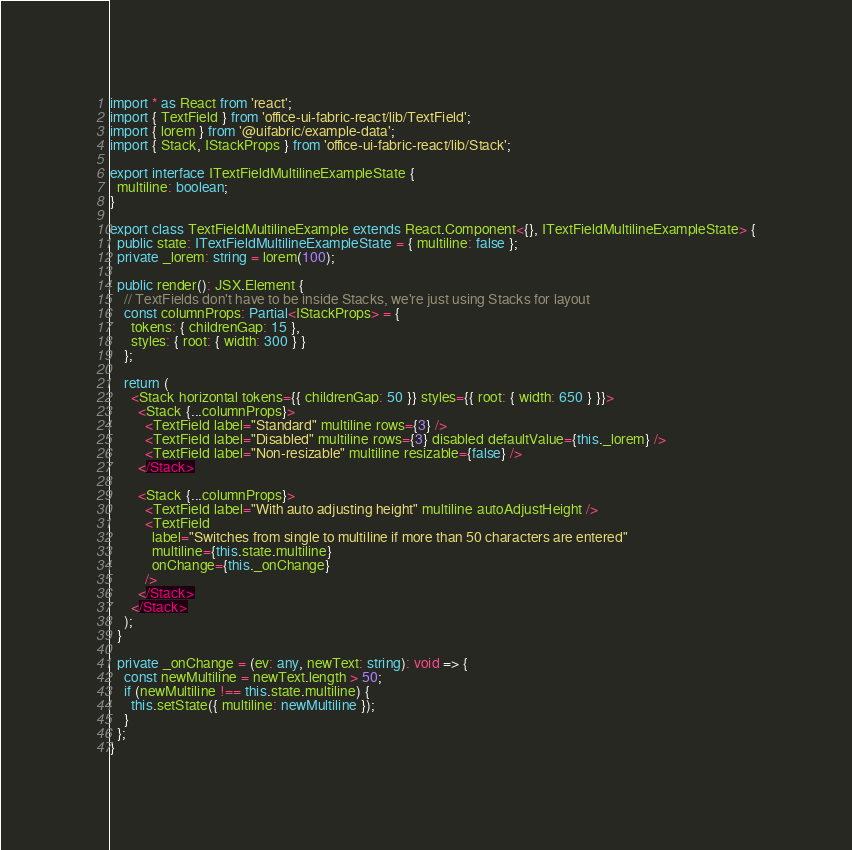Convert code to text. <code><loc_0><loc_0><loc_500><loc_500><_TypeScript_>import * as React from 'react';
import { TextField } from 'office-ui-fabric-react/lib/TextField';
import { lorem } from '@uifabric/example-data';
import { Stack, IStackProps } from 'office-ui-fabric-react/lib/Stack';

export interface ITextFieldMultilineExampleState {
  multiline: boolean;
}

export class TextFieldMultilineExample extends React.Component<{}, ITextFieldMultilineExampleState> {
  public state: ITextFieldMultilineExampleState = { multiline: false };
  private _lorem: string = lorem(100);

  public render(): JSX.Element {
    // TextFields don't have to be inside Stacks, we're just using Stacks for layout
    const columnProps: Partial<IStackProps> = {
      tokens: { childrenGap: 15 },
      styles: { root: { width: 300 } }
    };

    return (
      <Stack horizontal tokens={{ childrenGap: 50 }} styles={{ root: { width: 650 } }}>
        <Stack {...columnProps}>
          <TextField label="Standard" multiline rows={3} />
          <TextField label="Disabled" multiline rows={3} disabled defaultValue={this._lorem} />
          <TextField label="Non-resizable" multiline resizable={false} />
        </Stack>

        <Stack {...columnProps}>
          <TextField label="With auto adjusting height" multiline autoAdjustHeight />
          <TextField
            label="Switches from single to multiline if more than 50 characters are entered"
            multiline={this.state.multiline}
            onChange={this._onChange}
          />
        </Stack>
      </Stack>
    );
  }

  private _onChange = (ev: any, newText: string): void => {
    const newMultiline = newText.length > 50;
    if (newMultiline !== this.state.multiline) {
      this.setState({ multiline: newMultiline });
    }
  };
}
</code> 